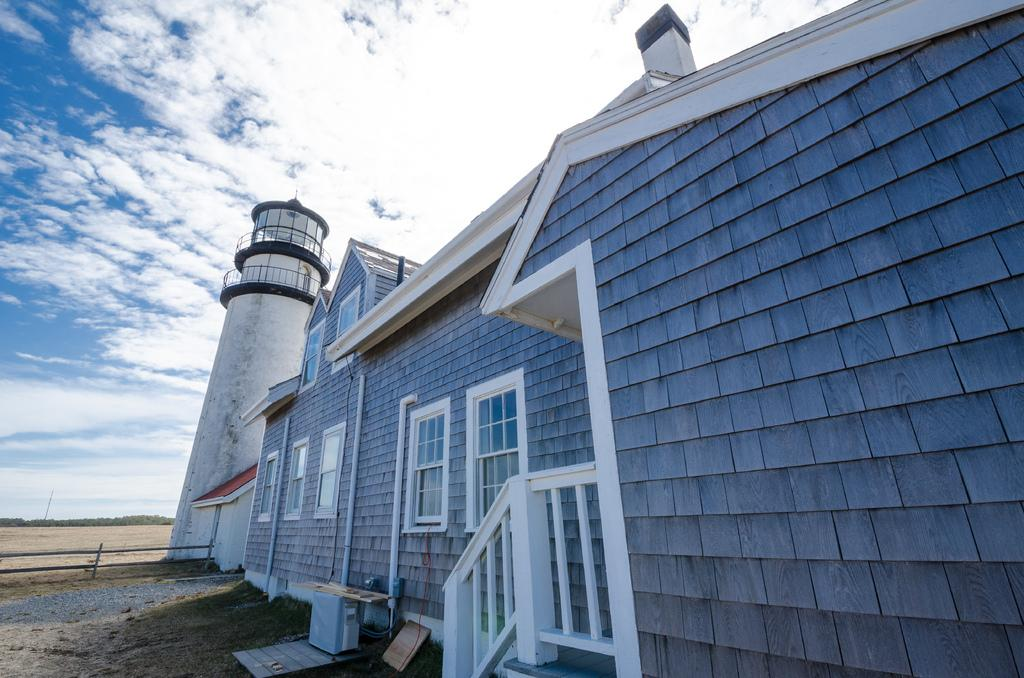What type of structure is present in the image? There is a house in the image. Are there any architectural features within the house? Yes, there are staircases in the image. What can be seen on the exterior of the house? There are windows and a fencing in the image. Is there any other prominent structure in the image? Yes, there is a tower in the image. What is visible in the sky in the image? There are clouds visible at the top of the image. What type of soda is being served in the house in the image? There is no indication of any soda being served or consumed in the image. Are there any boats visible in the image? No, there are no boats present in the image. 